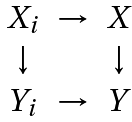Convert formula to latex. <formula><loc_0><loc_0><loc_500><loc_500>\begin{array} { c c c } X _ { i } & \to & X \\ \downarrow & & \downarrow \\ Y _ { i } & \to & Y \end{array}</formula> 